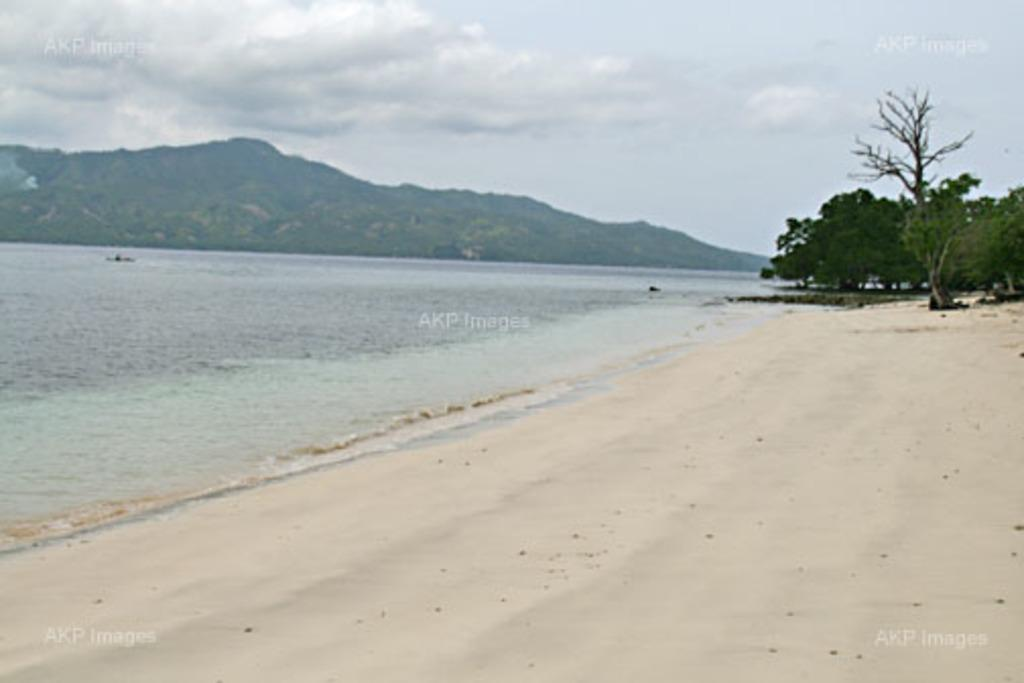What is the main feature of the image? There is water in the image, possibly a river or sea. What geographical feature can be seen in the image? There is a hill visible in the image. What type of vegetation is present in the image? There are trees in the image. What is visible in the sky in the image? Clouds are present in the sky in the image. How many cakes are being sold for profit in the image? There are no cakes or references to profit in the image. Can you see a mitten hanging on the tree in the image? There is no mitten present in the image. 